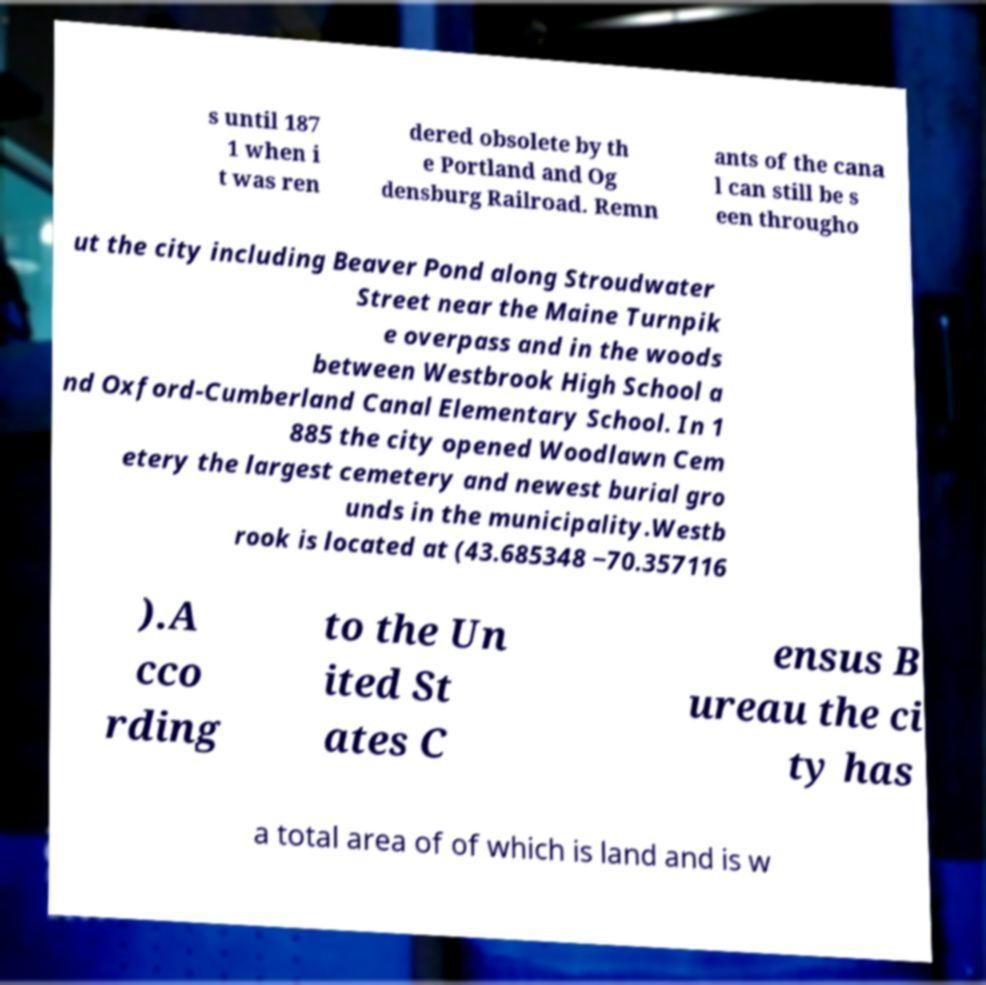There's text embedded in this image that I need extracted. Can you transcribe it verbatim? s until 187 1 when i t was ren dered obsolete by th e Portland and Og densburg Railroad. Remn ants of the cana l can still be s een througho ut the city including Beaver Pond along Stroudwater Street near the Maine Turnpik e overpass and in the woods between Westbrook High School a nd Oxford-Cumberland Canal Elementary School. In 1 885 the city opened Woodlawn Cem etery the largest cemetery and newest burial gro unds in the municipality.Westb rook is located at (43.685348 −70.357116 ).A cco rding to the Un ited St ates C ensus B ureau the ci ty has a total area of of which is land and is w 